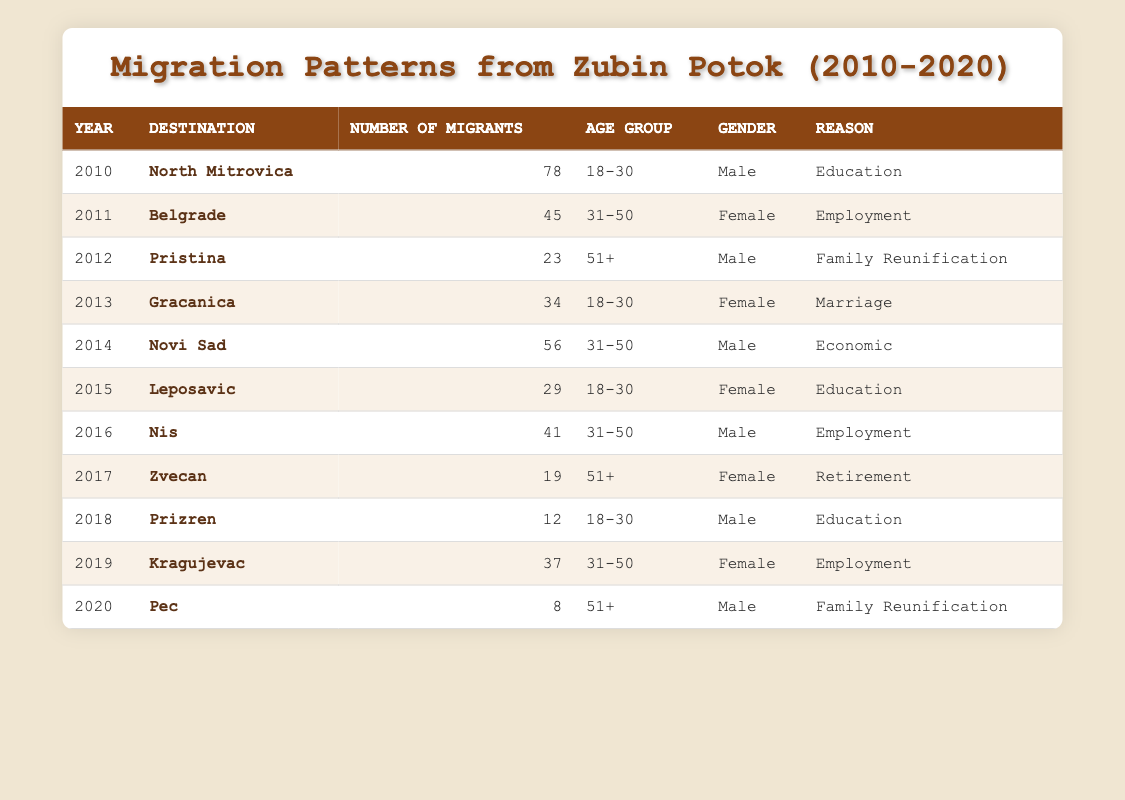What was the year with the highest number of migrants from Zubin Potok? By reviewing the table, we look for the row with the maximum value in the "Number of Migrants" column. The highest number is 78 in the year 2010.
Answer: 2010 How many migrants moved to North Mitrovica in 2010? The table directly states that 78 migrants moved to North Mitrovica in 2010.
Answer: 78 What was the total number of female migrants from Zubin Potok over the years? By filtering the table for female migrants, we sum the values from the "Number of Migrants" column where gender is female: 45 (2011) + 34 (2013) + 29 (2015) + 41 (2016) + 19 (2017) + 37 (2019) = 205.
Answer: 205 Did more female or male migrants move to Belgrade in 2011? In the table, it states that 45 female migrants moved to Belgrade in 2011, while there are no male migrants listed for that year, so we conclude that more female migrants moved.
Answer: Yes Which age group had the highest number of migrants to Pristina? Observing the table, only one male migrant aged 51+ moved to Pristina in 2012 with a total of 23. Therefore, there is no other age group for comparison for Pristina.
Answer: 51+ What is the total number of migrants who relocated for employment-related reasons? We identify rows related to employment: 45 (2011) + 41 (2016) + 37 (2019) = 123. So, the total for employment is 123 migrants.
Answer: 123 How many migrants moved to Pec in 2020, and what was their reason? The table specifies that 8 migrants moved to Pec in 2020, and their reason was family reunification.
Answer: 8, Family Reunification What was the average number of migrants from Zubin Potok per year for the years listed? Summing the number of migrants from each year gives us 78 + 45 + 23 + 34 + 56 + 29 + 41 + 19 + 12 + 37 + 8 = 362. Since there are 11 years listed, we calculate the average as 362/11 ≈ 32.91.
Answer: 32.91 Was there any migration related to retirement during the study period? The table shows that there were 19 female migrants who moved for retirement in 2017, therefore the answer is yes.
Answer: Yes 